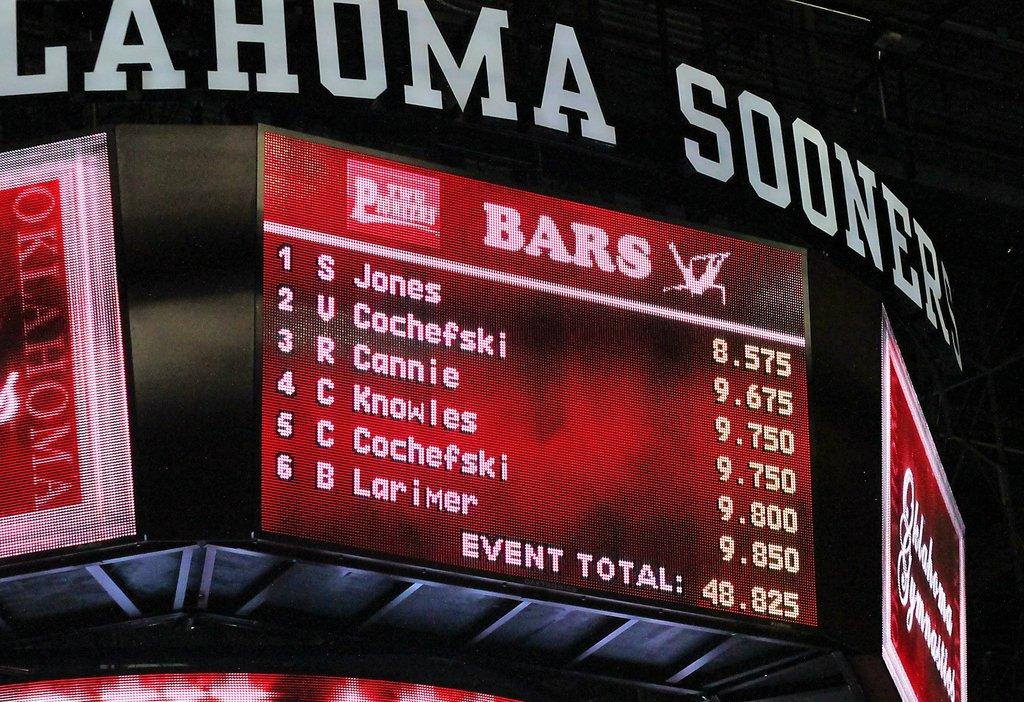<image>
Provide a brief description of the given image. Okalahoma Sooners Jumbo Tron Screen showing Bars and an event total of 48.825. 